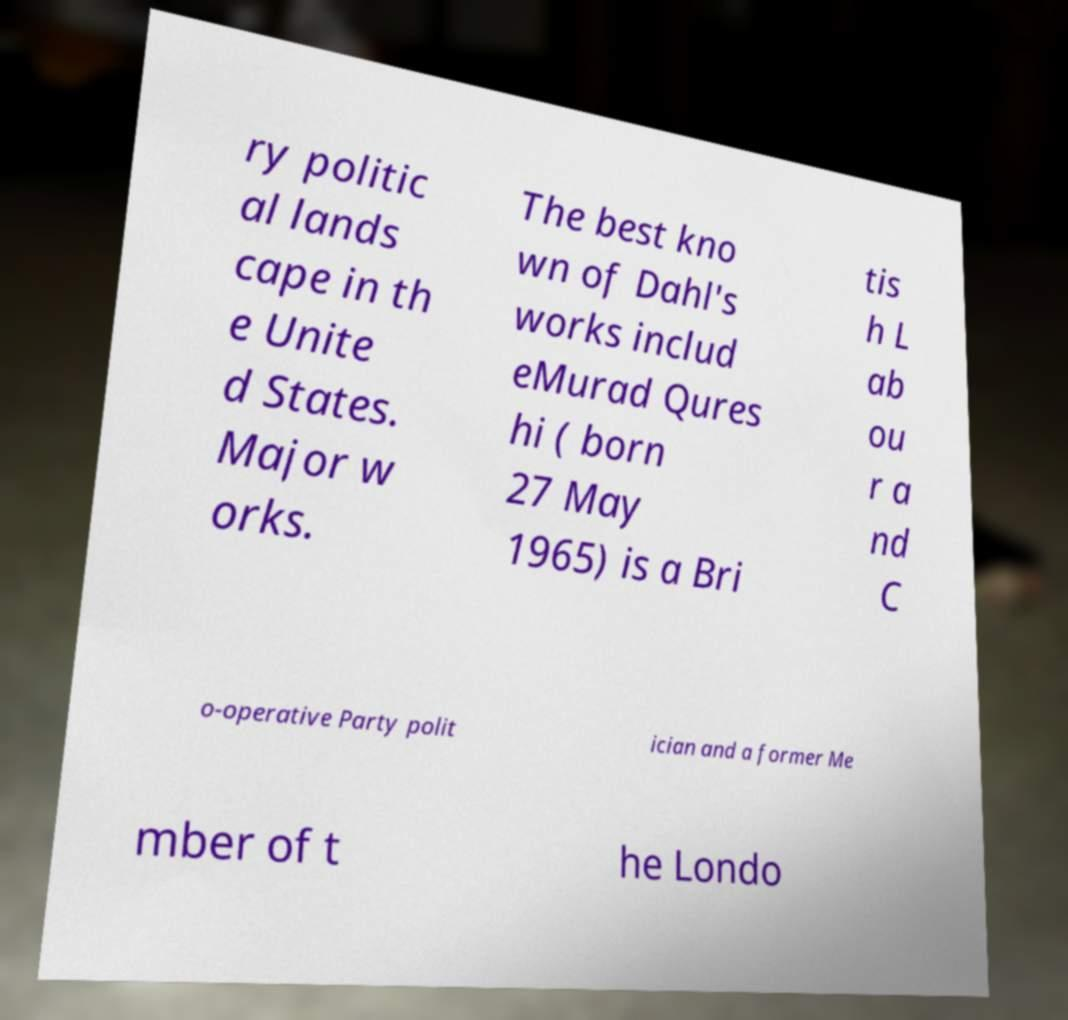Please identify and transcribe the text found in this image. ry politic al lands cape in th e Unite d States. Major w orks. The best kno wn of Dahl's works includ eMurad Qures hi ( born 27 May 1965) is a Bri tis h L ab ou r a nd C o-operative Party polit ician and a former Me mber of t he Londo 